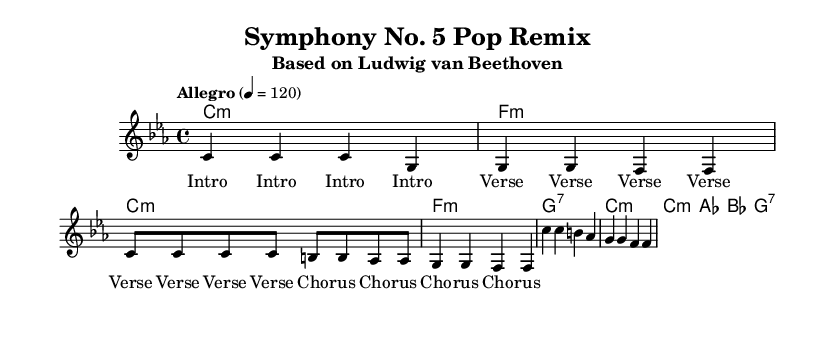What is the key signature of this music? The key signature is C minor, which has three flats (B♭, E♭, A♭). This is indicated at the beginning of the score.
Answer: C minor What is the time signature of this music? The time signature is 4/4, meaning there are four beats in each measure. This is indicated at the beginning of the score right after the key signature.
Answer: 4/4 What is the tempo marking of this music? The tempo marking is "Allegro", which means the piece should be played quickly. The specific tempo indicated is 120 beats per minute.
Answer: Allegro How many measures are in the verse section? The verse section consists of four measures as noted by the grouping of the music that corresponds to "Verse" in the lyrics.
Answer: 4 What chord type is used in the chorus? The chord type used in the chorus includes major chords, specifically A♭ major and B♭ major, as identified in the chord changes within that section.
Answer: Major Which historical composer is referenced in this arrangement? The referenced composer is Ludwig van Beethoven, noted in the subtitle of the score.
Answer: Ludwig van Beethoven What style is this arrangement embracing? The arrangement embraces a pop style, as indicated by the modern vocal arrangements and reinterpretation of classical material.
Answer: Pop 